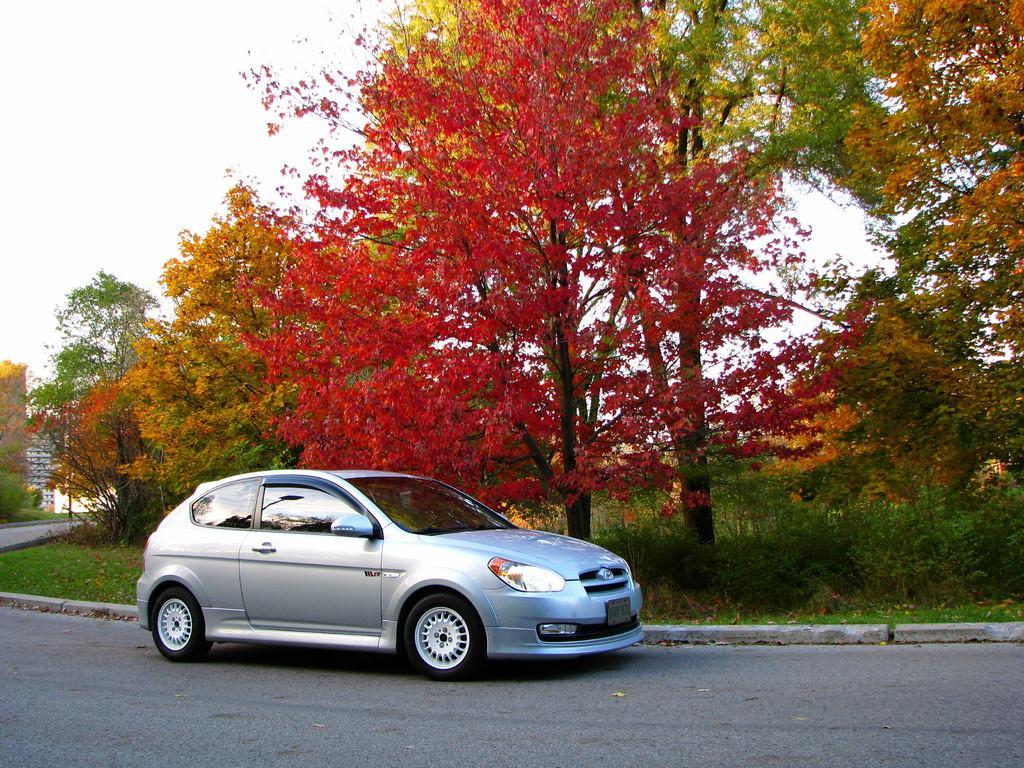Can you describe this image briefly? In this image I can see a road in the front and on it I can see a car. In the background I can see grass and number of trees. 